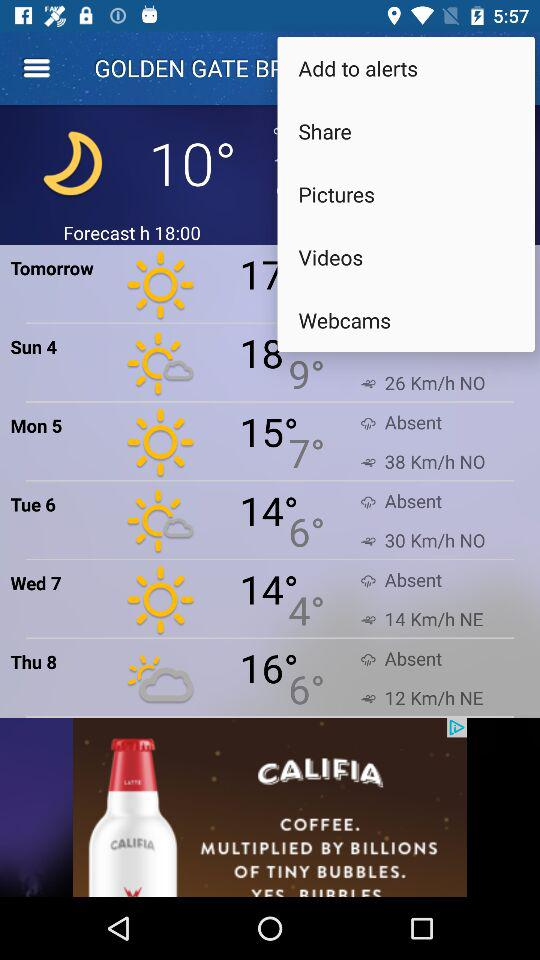What will be the expected wind speed on Tuesday 6? The wind speed is 30 km/h. 